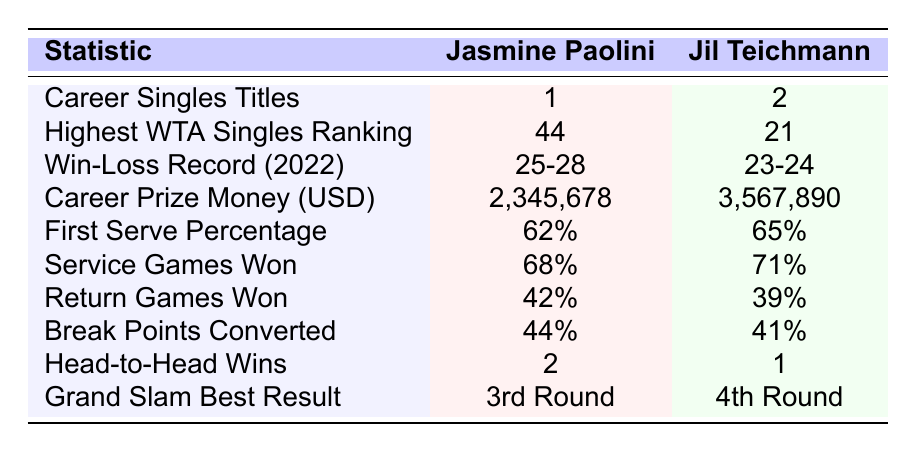What is Jasmine Paolini's highest WTA Singles ranking? The table lists the highest WTA Singles ranking for Jasmine Paolini as 44.
Answer: 44 How many career singles titles does Jil Teichmann have? According to the table, Jil Teichmann has 2 career singles titles.
Answer: 2 What is the win-loss record of Jasmine Paolini in 2022? The table states that Jasmine Paolini's win-loss record in 2022 is 25-28.
Answer: 25-28 What percentage of first serves did Jil Teichmann make? The table indicates that Jil Teichmann's first serve percentage is 65%.
Answer: 65% Who has a higher career prize money, Jasmine Paolini or Jil Teichmann? The table shows that Jasmine Paolini has earned $2,345,678, while Jil Teichmann has earned $3,567,890, making Jil Teichmann the winner in career prize money.
Answer: Jil Teichmann What is the difference in first serve percentages between the two players? Jasmine Paolini's first serve percentage is 62%, and Jil Teichmann's is 65%. The difference is 65% - 62% = 3%.
Answer: 3% Who has a better head-to-head record between Jasmine Paolini and Jil Teichmann? The table shows that Jasmine Paolini has won 2 matches against Jil Teichmann's 1, indicating a better head-to-head record for Jasmine Paolini.
Answer: Jasmine Paolini What is the total number of Grand Slam best results between Jasmine Paolini and Jil Teichmann? Jasmine Paolini's best result is 3rd Round and Jil Teichmann's is 4th Round. The total count of these distinct results is 2.
Answer: 2 Based on the 2022 win-loss records, who had a better performance? Jasmine Paolini had a win-loss record of 25-28 and Jil Teichmann had 23-24. A higher number of wins indicates better performance, so Jasmine Paolini had a slightly better performance despite the losing record.
Answer: Jasmine Paolini Is it true that Jil Teichmann has a higher percentage of service games won than Jasmine Paolini? Yes, the table shows that Jil Teichmann won 71% of her service games, which is higher than Jasmine Paolini's 68%.
Answer: Yes 